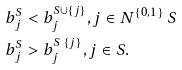<formula> <loc_0><loc_0><loc_500><loc_500>b ^ { S } _ { j } & < b ^ { S \cup \{ j \} } _ { j } , j \in N ^ { \{ 0 , 1 \} } \ S \\ b ^ { S } _ { j } & > b ^ { S \ \{ j \} } _ { j } , j \in S .</formula> 